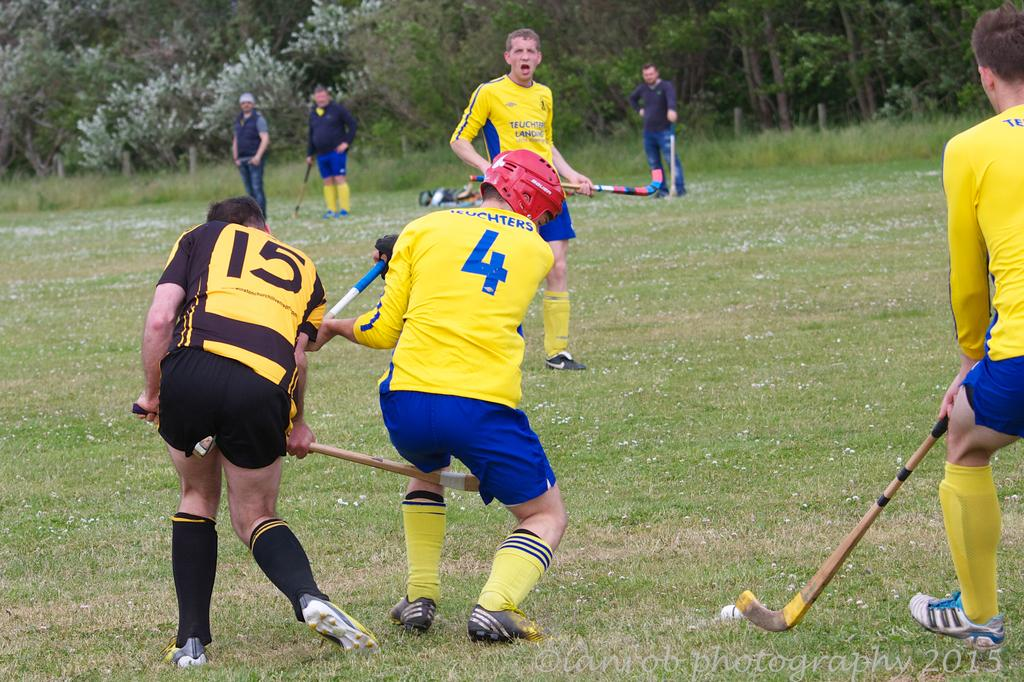<image>
Write a terse but informative summary of the picture. Player number 4 and 15 compete for the ball in this lacrosse game. 